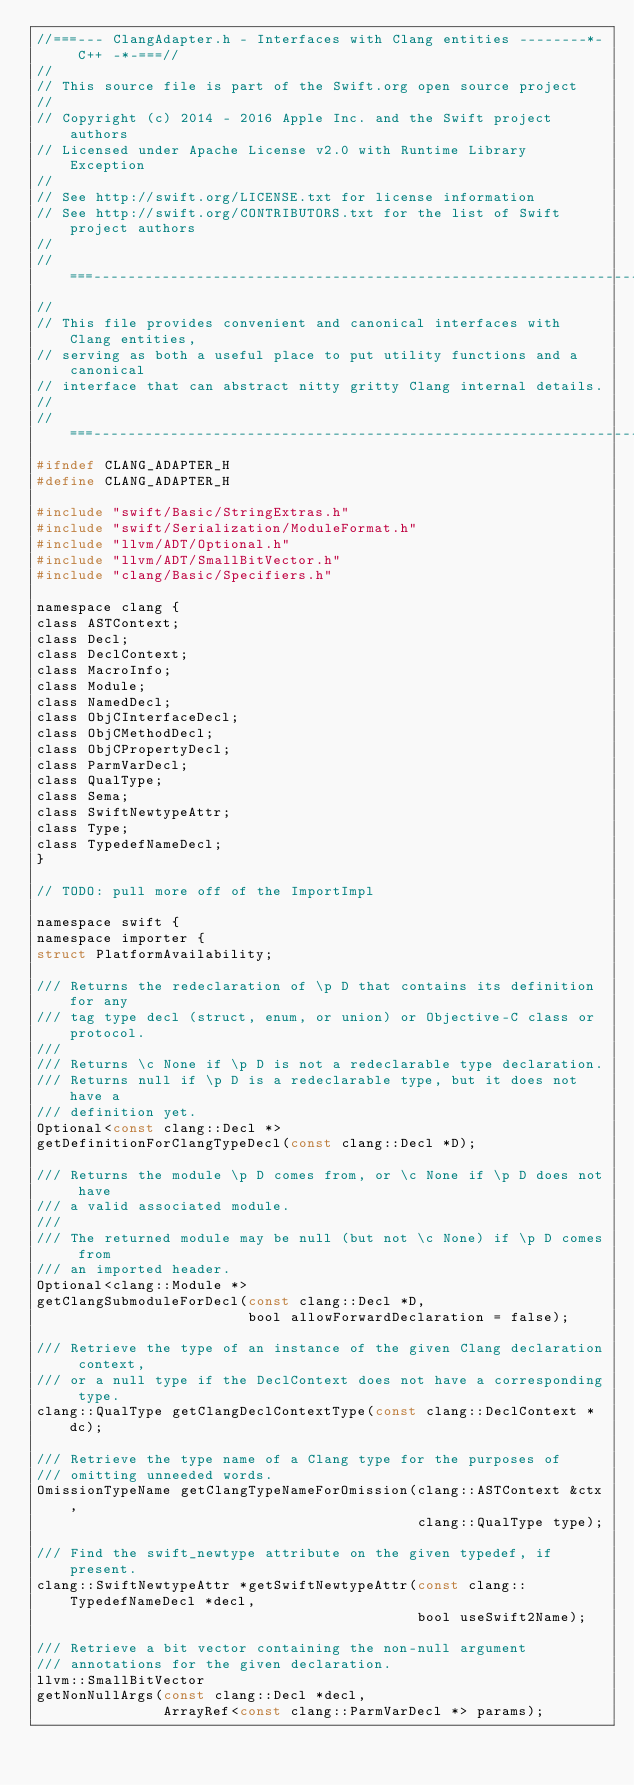Convert code to text. <code><loc_0><loc_0><loc_500><loc_500><_C_>//===--- ClangAdapter.h - Interfaces with Clang entities --------*- C++ -*-===//
//
// This source file is part of the Swift.org open source project
//
// Copyright (c) 2014 - 2016 Apple Inc. and the Swift project authors
// Licensed under Apache License v2.0 with Runtime Library Exception
//
// See http://swift.org/LICENSE.txt for license information
// See http://swift.org/CONTRIBUTORS.txt for the list of Swift project authors
//
//===----------------------------------------------------------------------===//
//
// This file provides convenient and canonical interfaces with Clang entities,
// serving as both a useful place to put utility functions and a canonical
// interface that can abstract nitty gritty Clang internal details.
//
//===----------------------------------------------------------------------===//
#ifndef CLANG_ADAPTER_H
#define CLANG_ADAPTER_H

#include "swift/Basic/StringExtras.h"
#include "swift/Serialization/ModuleFormat.h"
#include "llvm/ADT/Optional.h"
#include "llvm/ADT/SmallBitVector.h"
#include "clang/Basic/Specifiers.h"

namespace clang {
class ASTContext;
class Decl;
class DeclContext;
class MacroInfo;
class Module;
class NamedDecl;
class ObjCInterfaceDecl;
class ObjCMethodDecl;
class ObjCPropertyDecl;
class ParmVarDecl;
class QualType;
class Sema;
class SwiftNewtypeAttr;
class Type;
class TypedefNameDecl;
}

// TODO: pull more off of the ImportImpl

namespace swift {
namespace importer {
struct PlatformAvailability;

/// Returns the redeclaration of \p D that contains its definition for any
/// tag type decl (struct, enum, or union) or Objective-C class or protocol.
///
/// Returns \c None if \p D is not a redeclarable type declaration.
/// Returns null if \p D is a redeclarable type, but it does not have a
/// definition yet.
Optional<const clang::Decl *>
getDefinitionForClangTypeDecl(const clang::Decl *D);

/// Returns the module \p D comes from, or \c None if \p D does not have
/// a valid associated module.
///
/// The returned module may be null (but not \c None) if \p D comes from
/// an imported header.
Optional<clang::Module *>
getClangSubmoduleForDecl(const clang::Decl *D,
                         bool allowForwardDeclaration = false);

/// Retrieve the type of an instance of the given Clang declaration context,
/// or a null type if the DeclContext does not have a corresponding type.
clang::QualType getClangDeclContextType(const clang::DeclContext *dc);

/// Retrieve the type name of a Clang type for the purposes of
/// omitting unneeded words.
OmissionTypeName getClangTypeNameForOmission(clang::ASTContext &ctx,
                                             clang::QualType type);

/// Find the swift_newtype attribute on the given typedef, if present.
clang::SwiftNewtypeAttr *getSwiftNewtypeAttr(const clang::TypedefNameDecl *decl,
                                             bool useSwift2Name);

/// Retrieve a bit vector containing the non-null argument
/// annotations for the given declaration.
llvm::SmallBitVector
getNonNullArgs(const clang::Decl *decl,
               ArrayRef<const clang::ParmVarDecl *> params);
</code> 